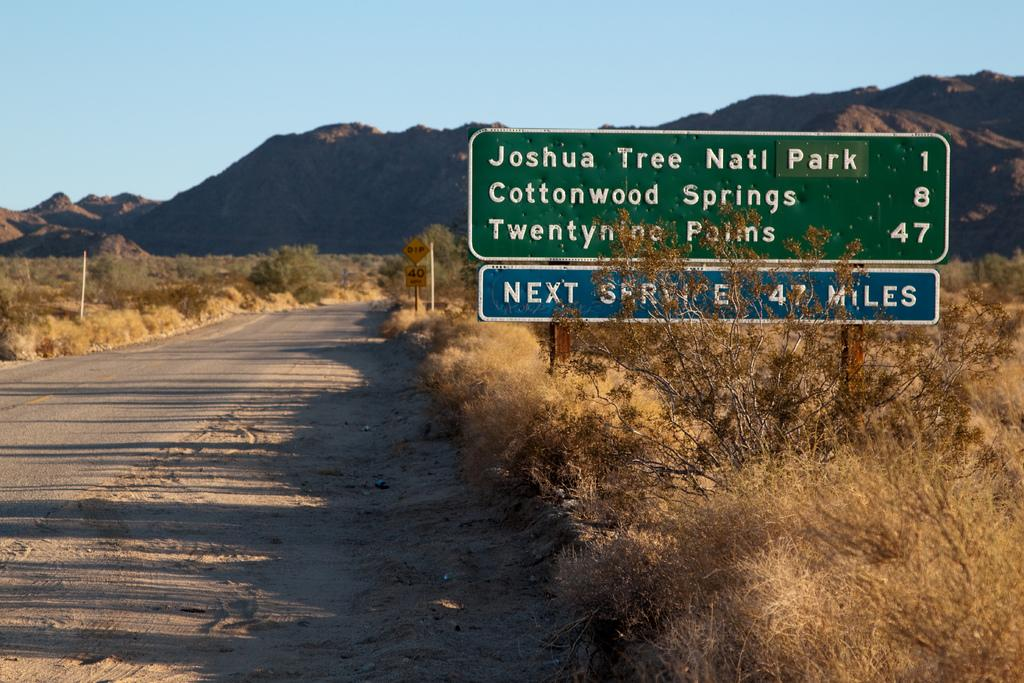What is attached to the pole in the image? There are sign boards attached to a pole in the image. What type of vegetation can be seen in the image? Dried bushes and trees are visible in the image. What is the nature of the road in the image? There is a road in the image. What information might the sign boards be conveying? It appears to be a speed limit board, so the sign boards might be conveying information about speed limits. What can be seen in the background of the image? There are mountains in the background of the image. Can you see any donkeys or lizards interacting with the stove in the image? There is no stove present in the image, and therefore no donkeys or lizards interacting with it. 